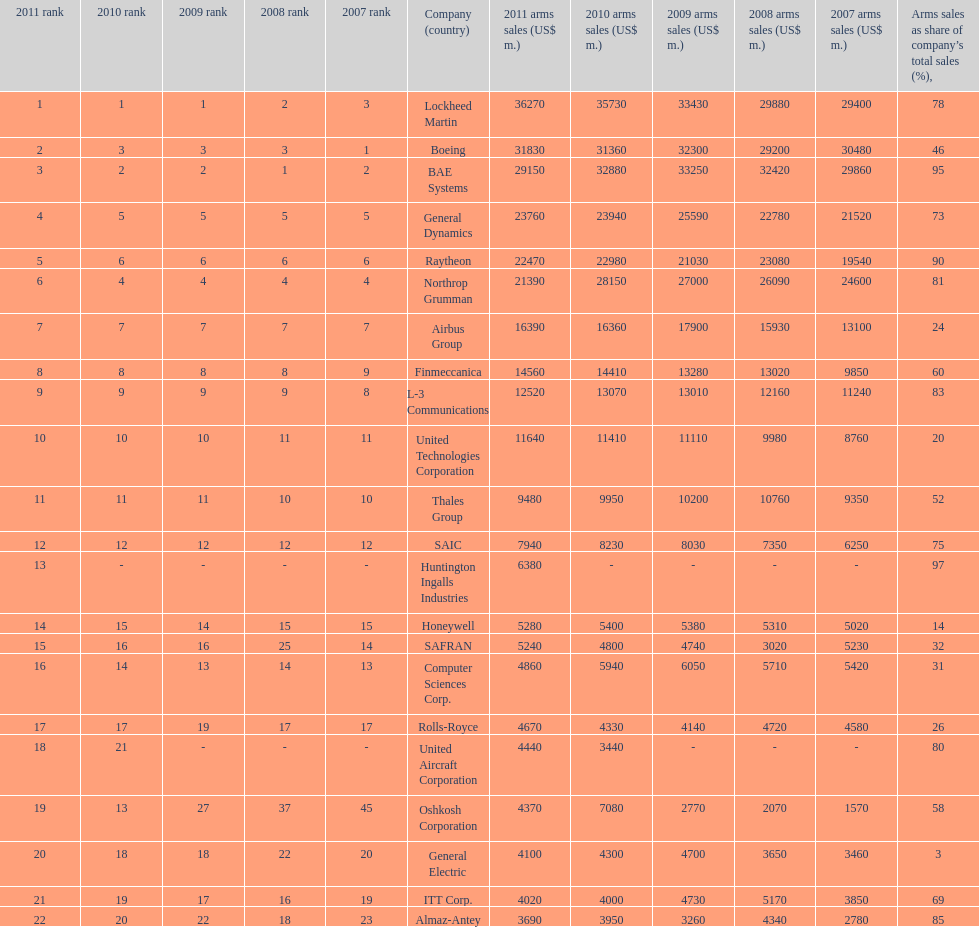How many corporations are within the united states? 14. 